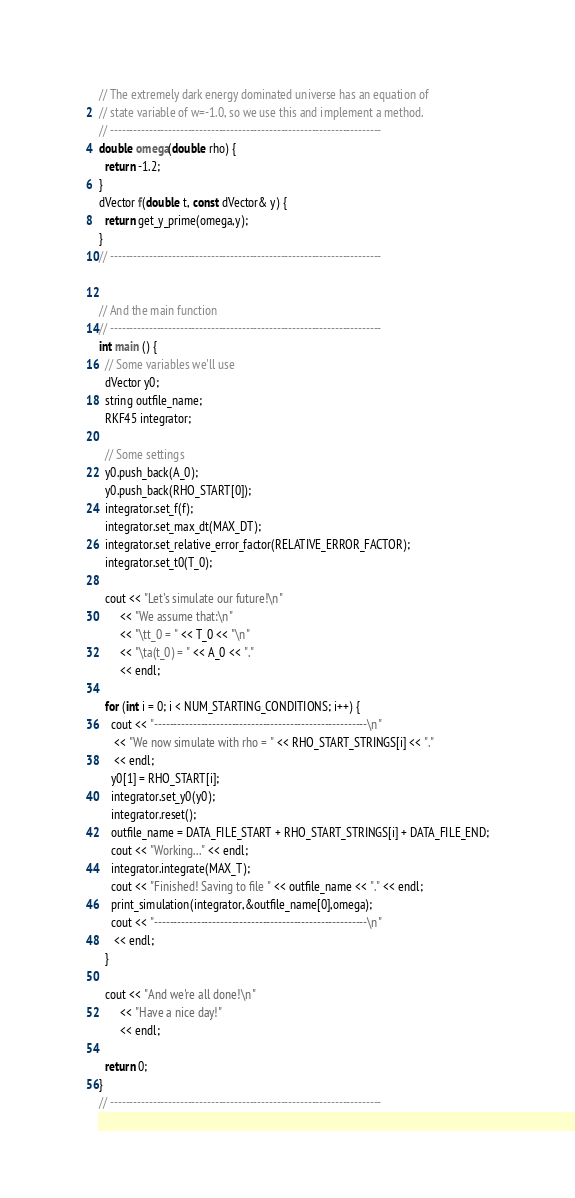Convert code to text. <code><loc_0><loc_0><loc_500><loc_500><_C++_>

// The extremely dark energy dominated universe has an equation of
// state variable of w=-1.0, so we use this and implement a method.
// ----------------------------------------------------------------------
double omega(double rho) {
  return -1.2;
}
dVector f(double t, const dVector& y) {
  return get_y_prime(omega,y);
}
// ----------------------------------------------------------------------


// And the main function
// ----------------------------------------------------------------------
int main () {
  // Some variables we'll use
  dVector y0;
  string outfile_name;
  RKF45 integrator;

  // Some settings
  y0.push_back(A_0);
  y0.push_back(RHO_START[0]);
  integrator.set_f(f);
  integrator.set_max_dt(MAX_DT);
  integrator.set_relative_error_factor(RELATIVE_ERROR_FACTOR);
  integrator.set_t0(T_0);

  cout << "Let's simulate our future!\n"
       << "We assume that:\n"
       << "\tt_0 = " << T_0 << "\n"
       << "\ta(t_0) = " << A_0 << "."
       << endl;

  for (int i = 0; i < NUM_STARTING_CONDITIONS; i++) {
    cout << "-------------------------------------------------------\n"
	 << "We now simulate with rho = " << RHO_START_STRINGS[i] << "."
	 << endl;
    y0[1] = RHO_START[i];
    integrator.set_y0(y0);
    integrator.reset();
    outfile_name = DATA_FILE_START + RHO_START_STRINGS[i] + DATA_FILE_END;
    cout << "Working..." << endl;
    integrator.integrate(MAX_T);
    cout << "Finished! Saving to file " << outfile_name << "." << endl;
    print_simulation(integrator,&outfile_name[0],omega);
    cout << "-------------------------------------------------------\n"
	 << endl;
  }

  cout << "And we're all done!\n"
       << "Have a nice day!"
       << endl;

  return 0;
}
// ----------------------------------------------------------------------
</code> 